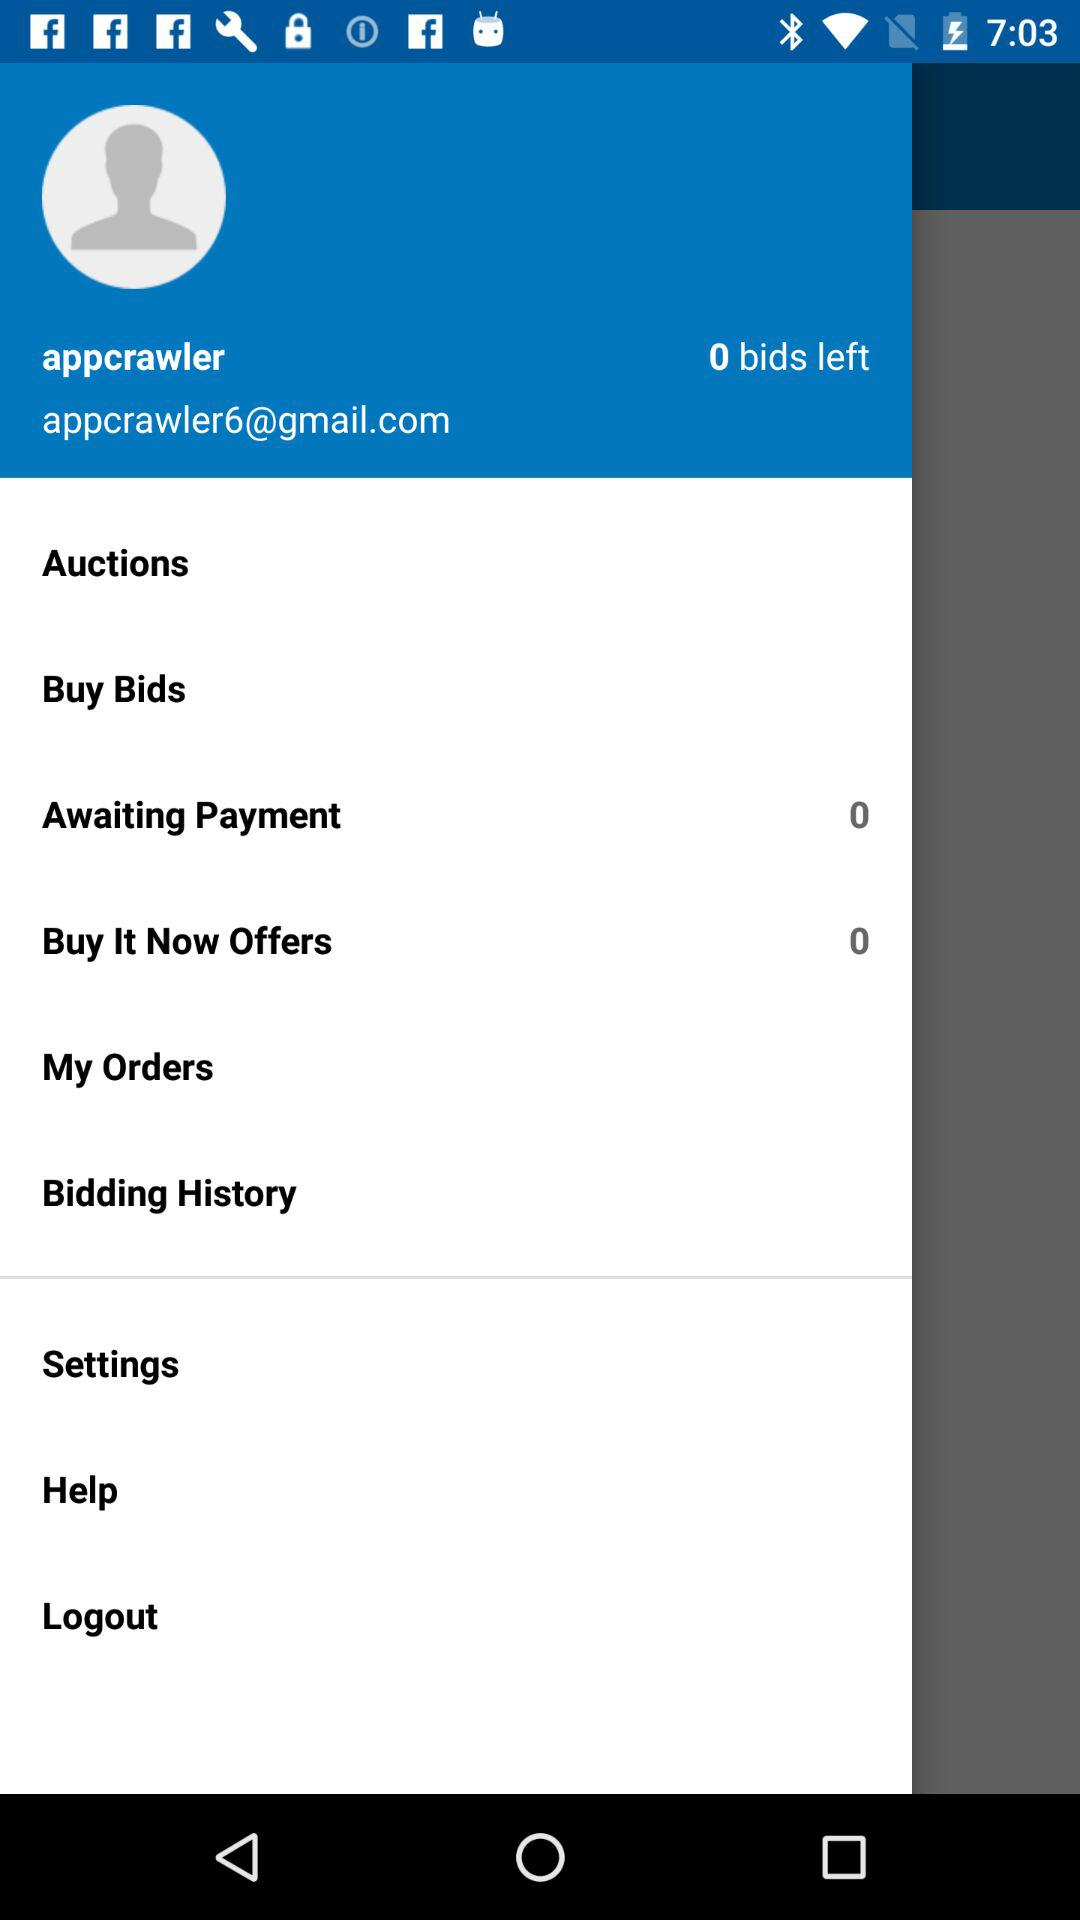How many bids do I have left?
Answer the question using a single word or phrase. 0 